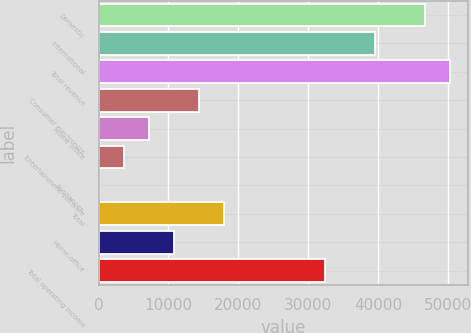Convert chart. <chart><loc_0><loc_0><loc_500><loc_500><bar_chart><fcel>Domestic<fcel>International<fcel>Total revenue<fcel>Consumer electronics<fcel>Home office<fcel>Entertainment software<fcel>Appliances<fcel>Total<fcel>Home-office<fcel>Total operating income<nl><fcel>46712.1<fcel>39526.7<fcel>50304.8<fcel>14377.8<fcel>7192.4<fcel>3599.7<fcel>7<fcel>17970.5<fcel>10785.1<fcel>32341.3<nl></chart> 